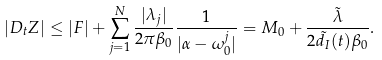Convert formula to latex. <formula><loc_0><loc_0><loc_500><loc_500>| D _ { t } Z | \leq | F | + \sum _ { j = 1 } ^ { N } \frac { | \lambda _ { j } | } { 2 \pi \beta _ { 0 } } \frac { 1 } { | \alpha - \omega _ { 0 } ^ { j } | } = M _ { 0 } + \frac { \tilde { \lambda } } { 2 \tilde { d } _ { I } ( t ) \beta _ { 0 } } .</formula> 